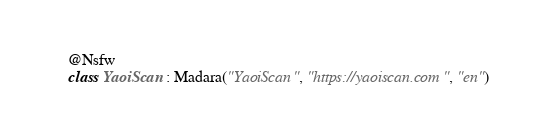Convert code to text. <code><loc_0><loc_0><loc_500><loc_500><_Kotlin_>@Nsfw
class YaoiScan : Madara("YaoiScan", "https://yaoiscan.com", "en")
</code> 